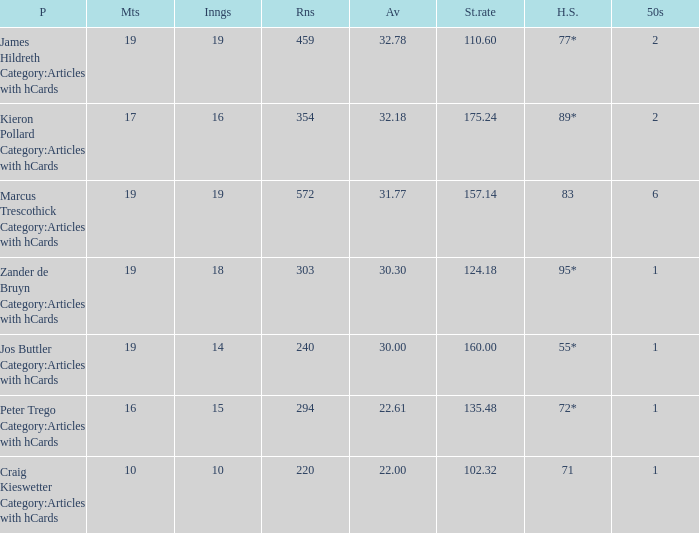What is the strike rate for the player with an average of 32.78? 110.6. Could you parse the entire table? {'header': ['P', 'Mts', 'Inngs', 'Rns', 'Av', 'St.rate', 'H.S.', '50s'], 'rows': [['James Hildreth Category:Articles with hCards', '19', '19', '459', '32.78', '110.60', '77*', '2'], ['Kieron Pollard Category:Articles with hCards', '17', '16', '354', '32.18', '175.24', '89*', '2'], ['Marcus Trescothick Category:Articles with hCards', '19', '19', '572', '31.77', '157.14', '83', '6'], ['Zander de Bruyn Category:Articles with hCards', '19', '18', '303', '30.30', '124.18', '95*', '1'], ['Jos Buttler Category:Articles with hCards', '19', '14', '240', '30.00', '160.00', '55*', '1'], ['Peter Trego Category:Articles with hCards', '16', '15', '294', '22.61', '135.48', '72*', '1'], ['Craig Kieswetter Category:Articles with hCards', '10', '10', '220', '22.00', '102.32', '71', '1']]} 